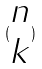<formula> <loc_0><loc_0><loc_500><loc_500>( \begin{matrix} n \\ k \end{matrix} )</formula> 